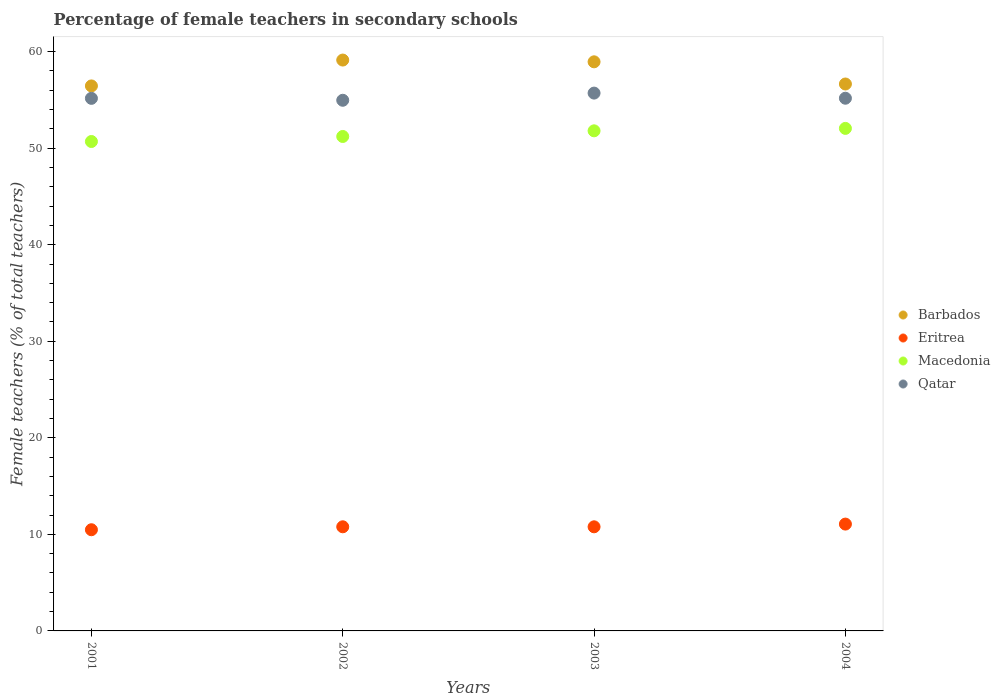How many different coloured dotlines are there?
Offer a terse response. 4. What is the percentage of female teachers in Barbados in 2004?
Ensure brevity in your answer.  56.65. Across all years, what is the maximum percentage of female teachers in Macedonia?
Offer a terse response. 52.05. Across all years, what is the minimum percentage of female teachers in Barbados?
Give a very brief answer. 56.45. In which year was the percentage of female teachers in Barbados minimum?
Your answer should be compact. 2001. What is the total percentage of female teachers in Barbados in the graph?
Ensure brevity in your answer.  231.16. What is the difference between the percentage of female teachers in Eritrea in 2001 and that in 2003?
Provide a short and direct response. -0.3. What is the difference between the percentage of female teachers in Macedonia in 2004 and the percentage of female teachers in Barbados in 2001?
Your answer should be compact. -4.4. What is the average percentage of female teachers in Eritrea per year?
Give a very brief answer. 10.78. In the year 2002, what is the difference between the percentage of female teachers in Eritrea and percentage of female teachers in Macedonia?
Offer a terse response. -40.43. In how many years, is the percentage of female teachers in Macedonia greater than 58 %?
Provide a succinct answer. 0. What is the ratio of the percentage of female teachers in Barbados in 2001 to that in 2003?
Your response must be concise. 0.96. Is the difference between the percentage of female teachers in Eritrea in 2001 and 2004 greater than the difference between the percentage of female teachers in Macedonia in 2001 and 2004?
Provide a short and direct response. Yes. What is the difference between the highest and the second highest percentage of female teachers in Qatar?
Ensure brevity in your answer.  0.53. What is the difference between the highest and the lowest percentage of female teachers in Eritrea?
Make the answer very short. 0.58. Is the percentage of female teachers in Qatar strictly less than the percentage of female teachers in Macedonia over the years?
Provide a succinct answer. No. Are the values on the major ticks of Y-axis written in scientific E-notation?
Make the answer very short. No. Does the graph contain any zero values?
Offer a terse response. No. Where does the legend appear in the graph?
Your answer should be very brief. Center right. How many legend labels are there?
Your answer should be very brief. 4. How are the legend labels stacked?
Provide a succinct answer. Vertical. What is the title of the graph?
Make the answer very short. Percentage of female teachers in secondary schools. Does "Kyrgyz Republic" appear as one of the legend labels in the graph?
Offer a terse response. No. What is the label or title of the X-axis?
Offer a terse response. Years. What is the label or title of the Y-axis?
Ensure brevity in your answer.  Female teachers (% of total teachers). What is the Female teachers (% of total teachers) in Barbados in 2001?
Give a very brief answer. 56.45. What is the Female teachers (% of total teachers) of Eritrea in 2001?
Ensure brevity in your answer.  10.48. What is the Female teachers (% of total teachers) in Macedonia in 2001?
Keep it short and to the point. 50.69. What is the Female teachers (% of total teachers) of Qatar in 2001?
Your answer should be very brief. 55.16. What is the Female teachers (% of total teachers) in Barbados in 2002?
Your answer should be compact. 59.13. What is the Female teachers (% of total teachers) in Eritrea in 2002?
Provide a short and direct response. 10.78. What is the Female teachers (% of total teachers) of Macedonia in 2002?
Your answer should be compact. 51.21. What is the Female teachers (% of total teachers) in Qatar in 2002?
Provide a short and direct response. 54.96. What is the Female teachers (% of total teachers) in Barbados in 2003?
Make the answer very short. 58.94. What is the Female teachers (% of total teachers) of Eritrea in 2003?
Your answer should be compact. 10.78. What is the Female teachers (% of total teachers) in Macedonia in 2003?
Offer a terse response. 51.8. What is the Female teachers (% of total teachers) of Qatar in 2003?
Offer a very short reply. 55.7. What is the Female teachers (% of total teachers) of Barbados in 2004?
Your answer should be compact. 56.65. What is the Female teachers (% of total teachers) in Eritrea in 2004?
Ensure brevity in your answer.  11.06. What is the Female teachers (% of total teachers) in Macedonia in 2004?
Make the answer very short. 52.05. What is the Female teachers (% of total teachers) in Qatar in 2004?
Offer a terse response. 55.17. Across all years, what is the maximum Female teachers (% of total teachers) in Barbados?
Give a very brief answer. 59.13. Across all years, what is the maximum Female teachers (% of total teachers) in Eritrea?
Give a very brief answer. 11.06. Across all years, what is the maximum Female teachers (% of total teachers) in Macedonia?
Ensure brevity in your answer.  52.05. Across all years, what is the maximum Female teachers (% of total teachers) in Qatar?
Your response must be concise. 55.7. Across all years, what is the minimum Female teachers (% of total teachers) in Barbados?
Provide a succinct answer. 56.45. Across all years, what is the minimum Female teachers (% of total teachers) of Eritrea?
Ensure brevity in your answer.  10.48. Across all years, what is the minimum Female teachers (% of total teachers) of Macedonia?
Give a very brief answer. 50.69. Across all years, what is the minimum Female teachers (% of total teachers) of Qatar?
Your response must be concise. 54.96. What is the total Female teachers (% of total teachers) of Barbados in the graph?
Ensure brevity in your answer.  231.16. What is the total Female teachers (% of total teachers) in Eritrea in the graph?
Your answer should be compact. 43.11. What is the total Female teachers (% of total teachers) in Macedonia in the graph?
Provide a succinct answer. 205.74. What is the total Female teachers (% of total teachers) of Qatar in the graph?
Provide a succinct answer. 220.99. What is the difference between the Female teachers (% of total teachers) in Barbados in 2001 and that in 2002?
Your answer should be very brief. -2.68. What is the difference between the Female teachers (% of total teachers) of Eritrea in 2001 and that in 2002?
Keep it short and to the point. -0.3. What is the difference between the Female teachers (% of total teachers) of Macedonia in 2001 and that in 2002?
Make the answer very short. -0.52. What is the difference between the Female teachers (% of total teachers) in Qatar in 2001 and that in 2002?
Make the answer very short. 0.2. What is the difference between the Female teachers (% of total teachers) of Barbados in 2001 and that in 2003?
Your response must be concise. -2.5. What is the difference between the Female teachers (% of total teachers) in Eritrea in 2001 and that in 2003?
Your answer should be compact. -0.3. What is the difference between the Female teachers (% of total teachers) of Macedonia in 2001 and that in 2003?
Your answer should be compact. -1.11. What is the difference between the Female teachers (% of total teachers) in Qatar in 2001 and that in 2003?
Offer a terse response. -0.54. What is the difference between the Female teachers (% of total teachers) of Barbados in 2001 and that in 2004?
Provide a succinct answer. -0.2. What is the difference between the Female teachers (% of total teachers) in Eritrea in 2001 and that in 2004?
Keep it short and to the point. -0.58. What is the difference between the Female teachers (% of total teachers) in Macedonia in 2001 and that in 2004?
Your answer should be compact. -1.36. What is the difference between the Female teachers (% of total teachers) of Qatar in 2001 and that in 2004?
Keep it short and to the point. -0.01. What is the difference between the Female teachers (% of total teachers) of Barbados in 2002 and that in 2003?
Offer a terse response. 0.18. What is the difference between the Female teachers (% of total teachers) of Eritrea in 2002 and that in 2003?
Keep it short and to the point. 0. What is the difference between the Female teachers (% of total teachers) of Macedonia in 2002 and that in 2003?
Your response must be concise. -0.59. What is the difference between the Female teachers (% of total teachers) of Qatar in 2002 and that in 2003?
Your answer should be compact. -0.74. What is the difference between the Female teachers (% of total teachers) of Barbados in 2002 and that in 2004?
Provide a succinct answer. 2.48. What is the difference between the Female teachers (% of total teachers) of Eritrea in 2002 and that in 2004?
Keep it short and to the point. -0.28. What is the difference between the Female teachers (% of total teachers) in Macedonia in 2002 and that in 2004?
Offer a very short reply. -0.84. What is the difference between the Female teachers (% of total teachers) of Qatar in 2002 and that in 2004?
Provide a succinct answer. -0.21. What is the difference between the Female teachers (% of total teachers) of Barbados in 2003 and that in 2004?
Your response must be concise. 2.3. What is the difference between the Female teachers (% of total teachers) of Eritrea in 2003 and that in 2004?
Offer a very short reply. -0.28. What is the difference between the Female teachers (% of total teachers) in Macedonia in 2003 and that in 2004?
Your answer should be compact. -0.25. What is the difference between the Female teachers (% of total teachers) of Qatar in 2003 and that in 2004?
Your answer should be very brief. 0.53. What is the difference between the Female teachers (% of total teachers) of Barbados in 2001 and the Female teachers (% of total teachers) of Eritrea in 2002?
Your answer should be very brief. 45.66. What is the difference between the Female teachers (% of total teachers) of Barbados in 2001 and the Female teachers (% of total teachers) of Macedonia in 2002?
Your answer should be compact. 5.24. What is the difference between the Female teachers (% of total teachers) of Barbados in 2001 and the Female teachers (% of total teachers) of Qatar in 2002?
Ensure brevity in your answer.  1.49. What is the difference between the Female teachers (% of total teachers) of Eritrea in 2001 and the Female teachers (% of total teachers) of Macedonia in 2002?
Ensure brevity in your answer.  -40.73. What is the difference between the Female teachers (% of total teachers) of Eritrea in 2001 and the Female teachers (% of total teachers) of Qatar in 2002?
Provide a short and direct response. -44.48. What is the difference between the Female teachers (% of total teachers) of Macedonia in 2001 and the Female teachers (% of total teachers) of Qatar in 2002?
Give a very brief answer. -4.27. What is the difference between the Female teachers (% of total teachers) in Barbados in 2001 and the Female teachers (% of total teachers) in Eritrea in 2003?
Provide a short and direct response. 45.66. What is the difference between the Female teachers (% of total teachers) in Barbados in 2001 and the Female teachers (% of total teachers) in Macedonia in 2003?
Your answer should be compact. 4.65. What is the difference between the Female teachers (% of total teachers) of Barbados in 2001 and the Female teachers (% of total teachers) of Qatar in 2003?
Provide a short and direct response. 0.74. What is the difference between the Female teachers (% of total teachers) of Eritrea in 2001 and the Female teachers (% of total teachers) of Macedonia in 2003?
Ensure brevity in your answer.  -41.32. What is the difference between the Female teachers (% of total teachers) of Eritrea in 2001 and the Female teachers (% of total teachers) of Qatar in 2003?
Offer a terse response. -45.22. What is the difference between the Female teachers (% of total teachers) in Macedonia in 2001 and the Female teachers (% of total teachers) in Qatar in 2003?
Provide a succinct answer. -5.01. What is the difference between the Female teachers (% of total teachers) of Barbados in 2001 and the Female teachers (% of total teachers) of Eritrea in 2004?
Offer a terse response. 45.38. What is the difference between the Female teachers (% of total teachers) of Barbados in 2001 and the Female teachers (% of total teachers) of Macedonia in 2004?
Keep it short and to the point. 4.4. What is the difference between the Female teachers (% of total teachers) in Barbados in 2001 and the Female teachers (% of total teachers) in Qatar in 2004?
Ensure brevity in your answer.  1.27. What is the difference between the Female teachers (% of total teachers) of Eritrea in 2001 and the Female teachers (% of total teachers) of Macedonia in 2004?
Offer a very short reply. -41.57. What is the difference between the Female teachers (% of total teachers) of Eritrea in 2001 and the Female teachers (% of total teachers) of Qatar in 2004?
Make the answer very short. -44.69. What is the difference between the Female teachers (% of total teachers) of Macedonia in 2001 and the Female teachers (% of total teachers) of Qatar in 2004?
Your response must be concise. -4.48. What is the difference between the Female teachers (% of total teachers) of Barbados in 2002 and the Female teachers (% of total teachers) of Eritrea in 2003?
Offer a terse response. 48.34. What is the difference between the Female teachers (% of total teachers) of Barbados in 2002 and the Female teachers (% of total teachers) of Macedonia in 2003?
Offer a very short reply. 7.33. What is the difference between the Female teachers (% of total teachers) of Barbados in 2002 and the Female teachers (% of total teachers) of Qatar in 2003?
Your response must be concise. 3.42. What is the difference between the Female teachers (% of total teachers) of Eritrea in 2002 and the Female teachers (% of total teachers) of Macedonia in 2003?
Keep it short and to the point. -41.01. What is the difference between the Female teachers (% of total teachers) in Eritrea in 2002 and the Female teachers (% of total teachers) in Qatar in 2003?
Make the answer very short. -44.92. What is the difference between the Female teachers (% of total teachers) in Macedonia in 2002 and the Female teachers (% of total teachers) in Qatar in 2003?
Keep it short and to the point. -4.49. What is the difference between the Female teachers (% of total teachers) of Barbados in 2002 and the Female teachers (% of total teachers) of Eritrea in 2004?
Keep it short and to the point. 48.06. What is the difference between the Female teachers (% of total teachers) of Barbados in 2002 and the Female teachers (% of total teachers) of Macedonia in 2004?
Provide a short and direct response. 7.08. What is the difference between the Female teachers (% of total teachers) of Barbados in 2002 and the Female teachers (% of total teachers) of Qatar in 2004?
Your answer should be compact. 3.95. What is the difference between the Female teachers (% of total teachers) of Eritrea in 2002 and the Female teachers (% of total teachers) of Macedonia in 2004?
Ensure brevity in your answer.  -41.26. What is the difference between the Female teachers (% of total teachers) of Eritrea in 2002 and the Female teachers (% of total teachers) of Qatar in 2004?
Offer a terse response. -44.39. What is the difference between the Female teachers (% of total teachers) of Macedonia in 2002 and the Female teachers (% of total teachers) of Qatar in 2004?
Offer a very short reply. -3.96. What is the difference between the Female teachers (% of total teachers) in Barbados in 2003 and the Female teachers (% of total teachers) in Eritrea in 2004?
Give a very brief answer. 47.88. What is the difference between the Female teachers (% of total teachers) of Barbados in 2003 and the Female teachers (% of total teachers) of Macedonia in 2004?
Keep it short and to the point. 6.9. What is the difference between the Female teachers (% of total teachers) in Barbados in 2003 and the Female teachers (% of total teachers) in Qatar in 2004?
Offer a very short reply. 3.77. What is the difference between the Female teachers (% of total teachers) of Eritrea in 2003 and the Female teachers (% of total teachers) of Macedonia in 2004?
Your response must be concise. -41.26. What is the difference between the Female teachers (% of total teachers) in Eritrea in 2003 and the Female teachers (% of total teachers) in Qatar in 2004?
Offer a very short reply. -44.39. What is the difference between the Female teachers (% of total teachers) in Macedonia in 2003 and the Female teachers (% of total teachers) in Qatar in 2004?
Provide a short and direct response. -3.38. What is the average Female teachers (% of total teachers) in Barbados per year?
Your response must be concise. 57.79. What is the average Female teachers (% of total teachers) in Eritrea per year?
Offer a very short reply. 10.78. What is the average Female teachers (% of total teachers) in Macedonia per year?
Keep it short and to the point. 51.44. What is the average Female teachers (% of total teachers) in Qatar per year?
Ensure brevity in your answer.  55.25. In the year 2001, what is the difference between the Female teachers (% of total teachers) of Barbados and Female teachers (% of total teachers) of Eritrea?
Make the answer very short. 45.97. In the year 2001, what is the difference between the Female teachers (% of total teachers) of Barbados and Female teachers (% of total teachers) of Macedonia?
Ensure brevity in your answer.  5.76. In the year 2001, what is the difference between the Female teachers (% of total teachers) in Barbados and Female teachers (% of total teachers) in Qatar?
Your answer should be very brief. 1.29. In the year 2001, what is the difference between the Female teachers (% of total teachers) in Eritrea and Female teachers (% of total teachers) in Macedonia?
Provide a short and direct response. -40.21. In the year 2001, what is the difference between the Female teachers (% of total teachers) in Eritrea and Female teachers (% of total teachers) in Qatar?
Ensure brevity in your answer.  -44.68. In the year 2001, what is the difference between the Female teachers (% of total teachers) of Macedonia and Female teachers (% of total teachers) of Qatar?
Give a very brief answer. -4.47. In the year 2002, what is the difference between the Female teachers (% of total teachers) of Barbados and Female teachers (% of total teachers) of Eritrea?
Provide a succinct answer. 48.34. In the year 2002, what is the difference between the Female teachers (% of total teachers) in Barbados and Female teachers (% of total teachers) in Macedonia?
Offer a very short reply. 7.91. In the year 2002, what is the difference between the Female teachers (% of total teachers) in Barbados and Female teachers (% of total teachers) in Qatar?
Your answer should be compact. 4.16. In the year 2002, what is the difference between the Female teachers (% of total teachers) of Eritrea and Female teachers (% of total teachers) of Macedonia?
Ensure brevity in your answer.  -40.43. In the year 2002, what is the difference between the Female teachers (% of total teachers) in Eritrea and Female teachers (% of total teachers) in Qatar?
Give a very brief answer. -44.18. In the year 2002, what is the difference between the Female teachers (% of total teachers) of Macedonia and Female teachers (% of total teachers) of Qatar?
Your response must be concise. -3.75. In the year 2003, what is the difference between the Female teachers (% of total teachers) of Barbados and Female teachers (% of total teachers) of Eritrea?
Provide a short and direct response. 48.16. In the year 2003, what is the difference between the Female teachers (% of total teachers) of Barbados and Female teachers (% of total teachers) of Macedonia?
Your answer should be compact. 7.15. In the year 2003, what is the difference between the Female teachers (% of total teachers) in Barbados and Female teachers (% of total teachers) in Qatar?
Keep it short and to the point. 3.24. In the year 2003, what is the difference between the Female teachers (% of total teachers) of Eritrea and Female teachers (% of total teachers) of Macedonia?
Provide a short and direct response. -41.01. In the year 2003, what is the difference between the Female teachers (% of total teachers) of Eritrea and Female teachers (% of total teachers) of Qatar?
Offer a terse response. -44.92. In the year 2003, what is the difference between the Female teachers (% of total teachers) in Macedonia and Female teachers (% of total teachers) in Qatar?
Provide a succinct answer. -3.91. In the year 2004, what is the difference between the Female teachers (% of total teachers) in Barbados and Female teachers (% of total teachers) in Eritrea?
Provide a short and direct response. 45.58. In the year 2004, what is the difference between the Female teachers (% of total teachers) in Barbados and Female teachers (% of total teachers) in Macedonia?
Your answer should be compact. 4.6. In the year 2004, what is the difference between the Female teachers (% of total teachers) of Barbados and Female teachers (% of total teachers) of Qatar?
Provide a succinct answer. 1.47. In the year 2004, what is the difference between the Female teachers (% of total teachers) of Eritrea and Female teachers (% of total teachers) of Macedonia?
Offer a very short reply. -40.98. In the year 2004, what is the difference between the Female teachers (% of total teachers) of Eritrea and Female teachers (% of total teachers) of Qatar?
Make the answer very short. -44.11. In the year 2004, what is the difference between the Female teachers (% of total teachers) of Macedonia and Female teachers (% of total teachers) of Qatar?
Provide a succinct answer. -3.12. What is the ratio of the Female teachers (% of total teachers) in Barbados in 2001 to that in 2002?
Provide a succinct answer. 0.95. What is the ratio of the Female teachers (% of total teachers) in Eritrea in 2001 to that in 2002?
Make the answer very short. 0.97. What is the ratio of the Female teachers (% of total teachers) of Macedonia in 2001 to that in 2002?
Provide a short and direct response. 0.99. What is the ratio of the Female teachers (% of total teachers) in Qatar in 2001 to that in 2002?
Offer a very short reply. 1. What is the ratio of the Female teachers (% of total teachers) of Barbados in 2001 to that in 2003?
Your answer should be compact. 0.96. What is the ratio of the Female teachers (% of total teachers) of Eritrea in 2001 to that in 2003?
Your response must be concise. 0.97. What is the ratio of the Female teachers (% of total teachers) of Macedonia in 2001 to that in 2003?
Provide a succinct answer. 0.98. What is the ratio of the Female teachers (% of total teachers) of Qatar in 2001 to that in 2003?
Offer a terse response. 0.99. What is the ratio of the Female teachers (% of total teachers) in Barbados in 2001 to that in 2004?
Ensure brevity in your answer.  1. What is the ratio of the Female teachers (% of total teachers) in Eritrea in 2001 to that in 2004?
Your response must be concise. 0.95. What is the ratio of the Female teachers (% of total teachers) of Macedonia in 2001 to that in 2004?
Make the answer very short. 0.97. What is the ratio of the Female teachers (% of total teachers) in Qatar in 2001 to that in 2004?
Your answer should be compact. 1. What is the ratio of the Female teachers (% of total teachers) of Eritrea in 2002 to that in 2003?
Provide a succinct answer. 1. What is the ratio of the Female teachers (% of total teachers) in Macedonia in 2002 to that in 2003?
Offer a terse response. 0.99. What is the ratio of the Female teachers (% of total teachers) of Qatar in 2002 to that in 2003?
Offer a very short reply. 0.99. What is the ratio of the Female teachers (% of total teachers) of Barbados in 2002 to that in 2004?
Offer a very short reply. 1.04. What is the ratio of the Female teachers (% of total teachers) of Eritrea in 2002 to that in 2004?
Provide a short and direct response. 0.97. What is the ratio of the Female teachers (% of total teachers) in Macedonia in 2002 to that in 2004?
Make the answer very short. 0.98. What is the ratio of the Female teachers (% of total teachers) in Qatar in 2002 to that in 2004?
Ensure brevity in your answer.  1. What is the ratio of the Female teachers (% of total teachers) of Barbados in 2003 to that in 2004?
Offer a very short reply. 1.04. What is the ratio of the Female teachers (% of total teachers) of Eritrea in 2003 to that in 2004?
Offer a very short reply. 0.97. What is the ratio of the Female teachers (% of total teachers) in Qatar in 2003 to that in 2004?
Keep it short and to the point. 1.01. What is the difference between the highest and the second highest Female teachers (% of total teachers) of Barbados?
Your response must be concise. 0.18. What is the difference between the highest and the second highest Female teachers (% of total teachers) of Eritrea?
Ensure brevity in your answer.  0.28. What is the difference between the highest and the second highest Female teachers (% of total teachers) in Macedonia?
Offer a very short reply. 0.25. What is the difference between the highest and the second highest Female teachers (% of total teachers) in Qatar?
Your answer should be compact. 0.53. What is the difference between the highest and the lowest Female teachers (% of total teachers) in Barbados?
Give a very brief answer. 2.68. What is the difference between the highest and the lowest Female teachers (% of total teachers) in Eritrea?
Your answer should be very brief. 0.58. What is the difference between the highest and the lowest Female teachers (% of total teachers) in Macedonia?
Provide a succinct answer. 1.36. What is the difference between the highest and the lowest Female teachers (% of total teachers) of Qatar?
Your answer should be compact. 0.74. 